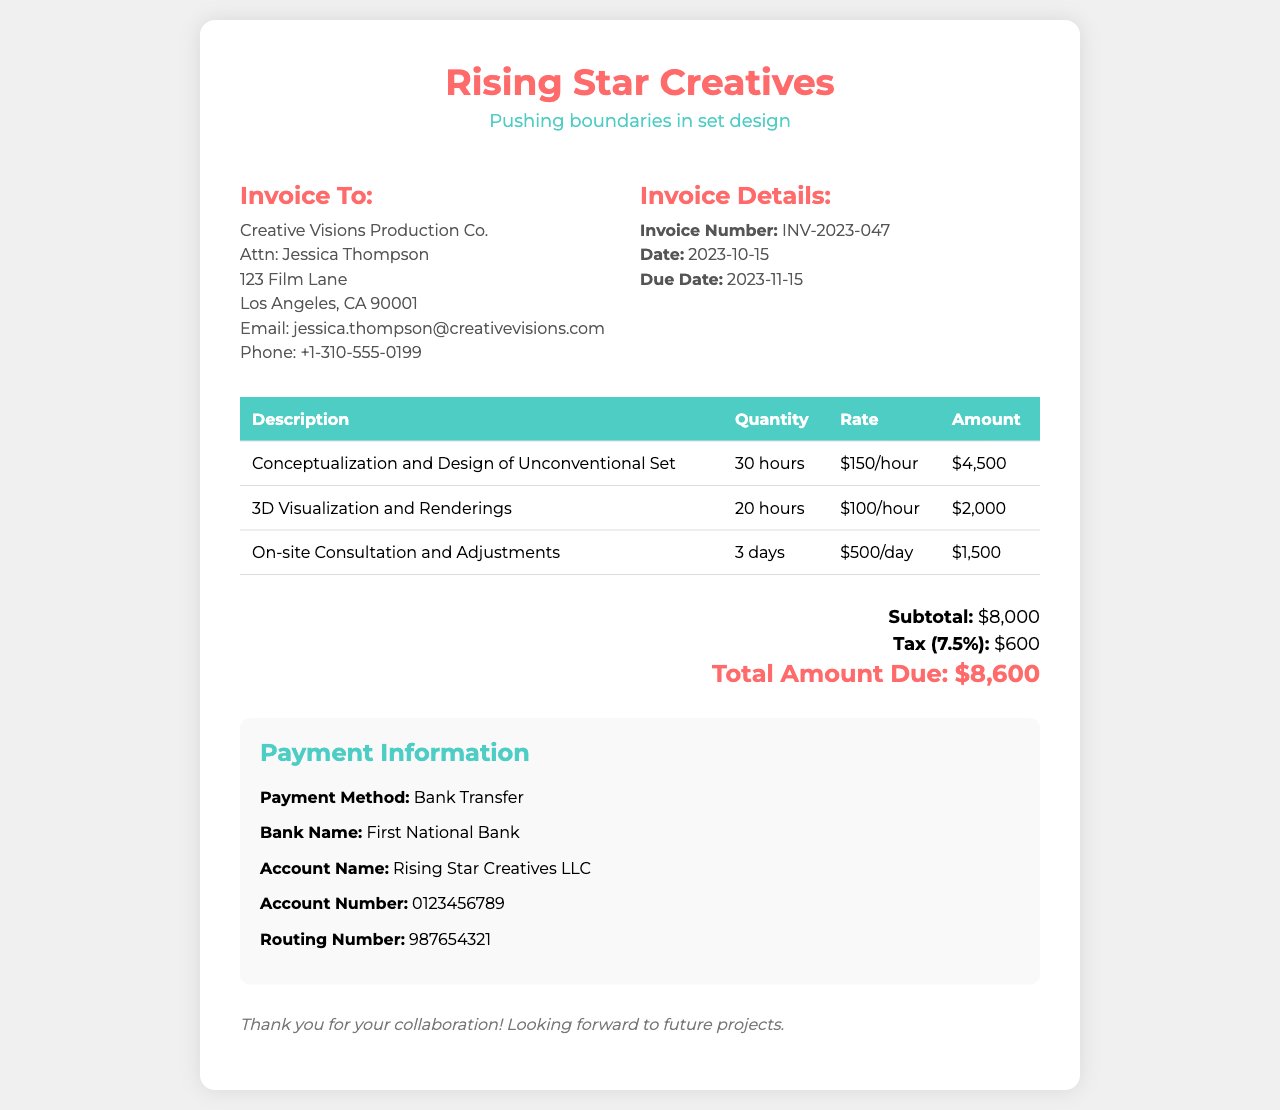What is the invoice number? The invoice number is clearly stated in the document and is used for reference.
Answer: INV-2023-047 Who is the invoice addressed to? The recipient's details, including name and company, are provided in the invoice.
Answer: Creative Visions Production Co What is the subtotal amount? The subtotal amount is provided in the total section of the invoice, which breaks down the costs before tax.
Answer: $8,000 What is the tax rate applied? The tax amount is calculated based on the subtotal, and the rate is specified in the document.
Answer: 7.5% How many hours were spent on conceptualization and design? The description of services includes the quantity of hours allocated to specific tasks.
Answer: 30 hours What is the total amount due? The total amount due combines the subtotal and tax for the final charge, stated clearly at the end of the invoice.
Answer: $8,600 What payment method is specified? The payment method is detailed in the payment information section of the invoice.
Answer: Bank Transfer What is the due date for the invoice payment? The due date is explicitly noted in the invoice details.
Answer: 2023-11-15 What is the account name for the bank transfer? The account name is included in the payment information section, which specifies how the payment should be made.
Answer: Rising Star Creatives LLC 